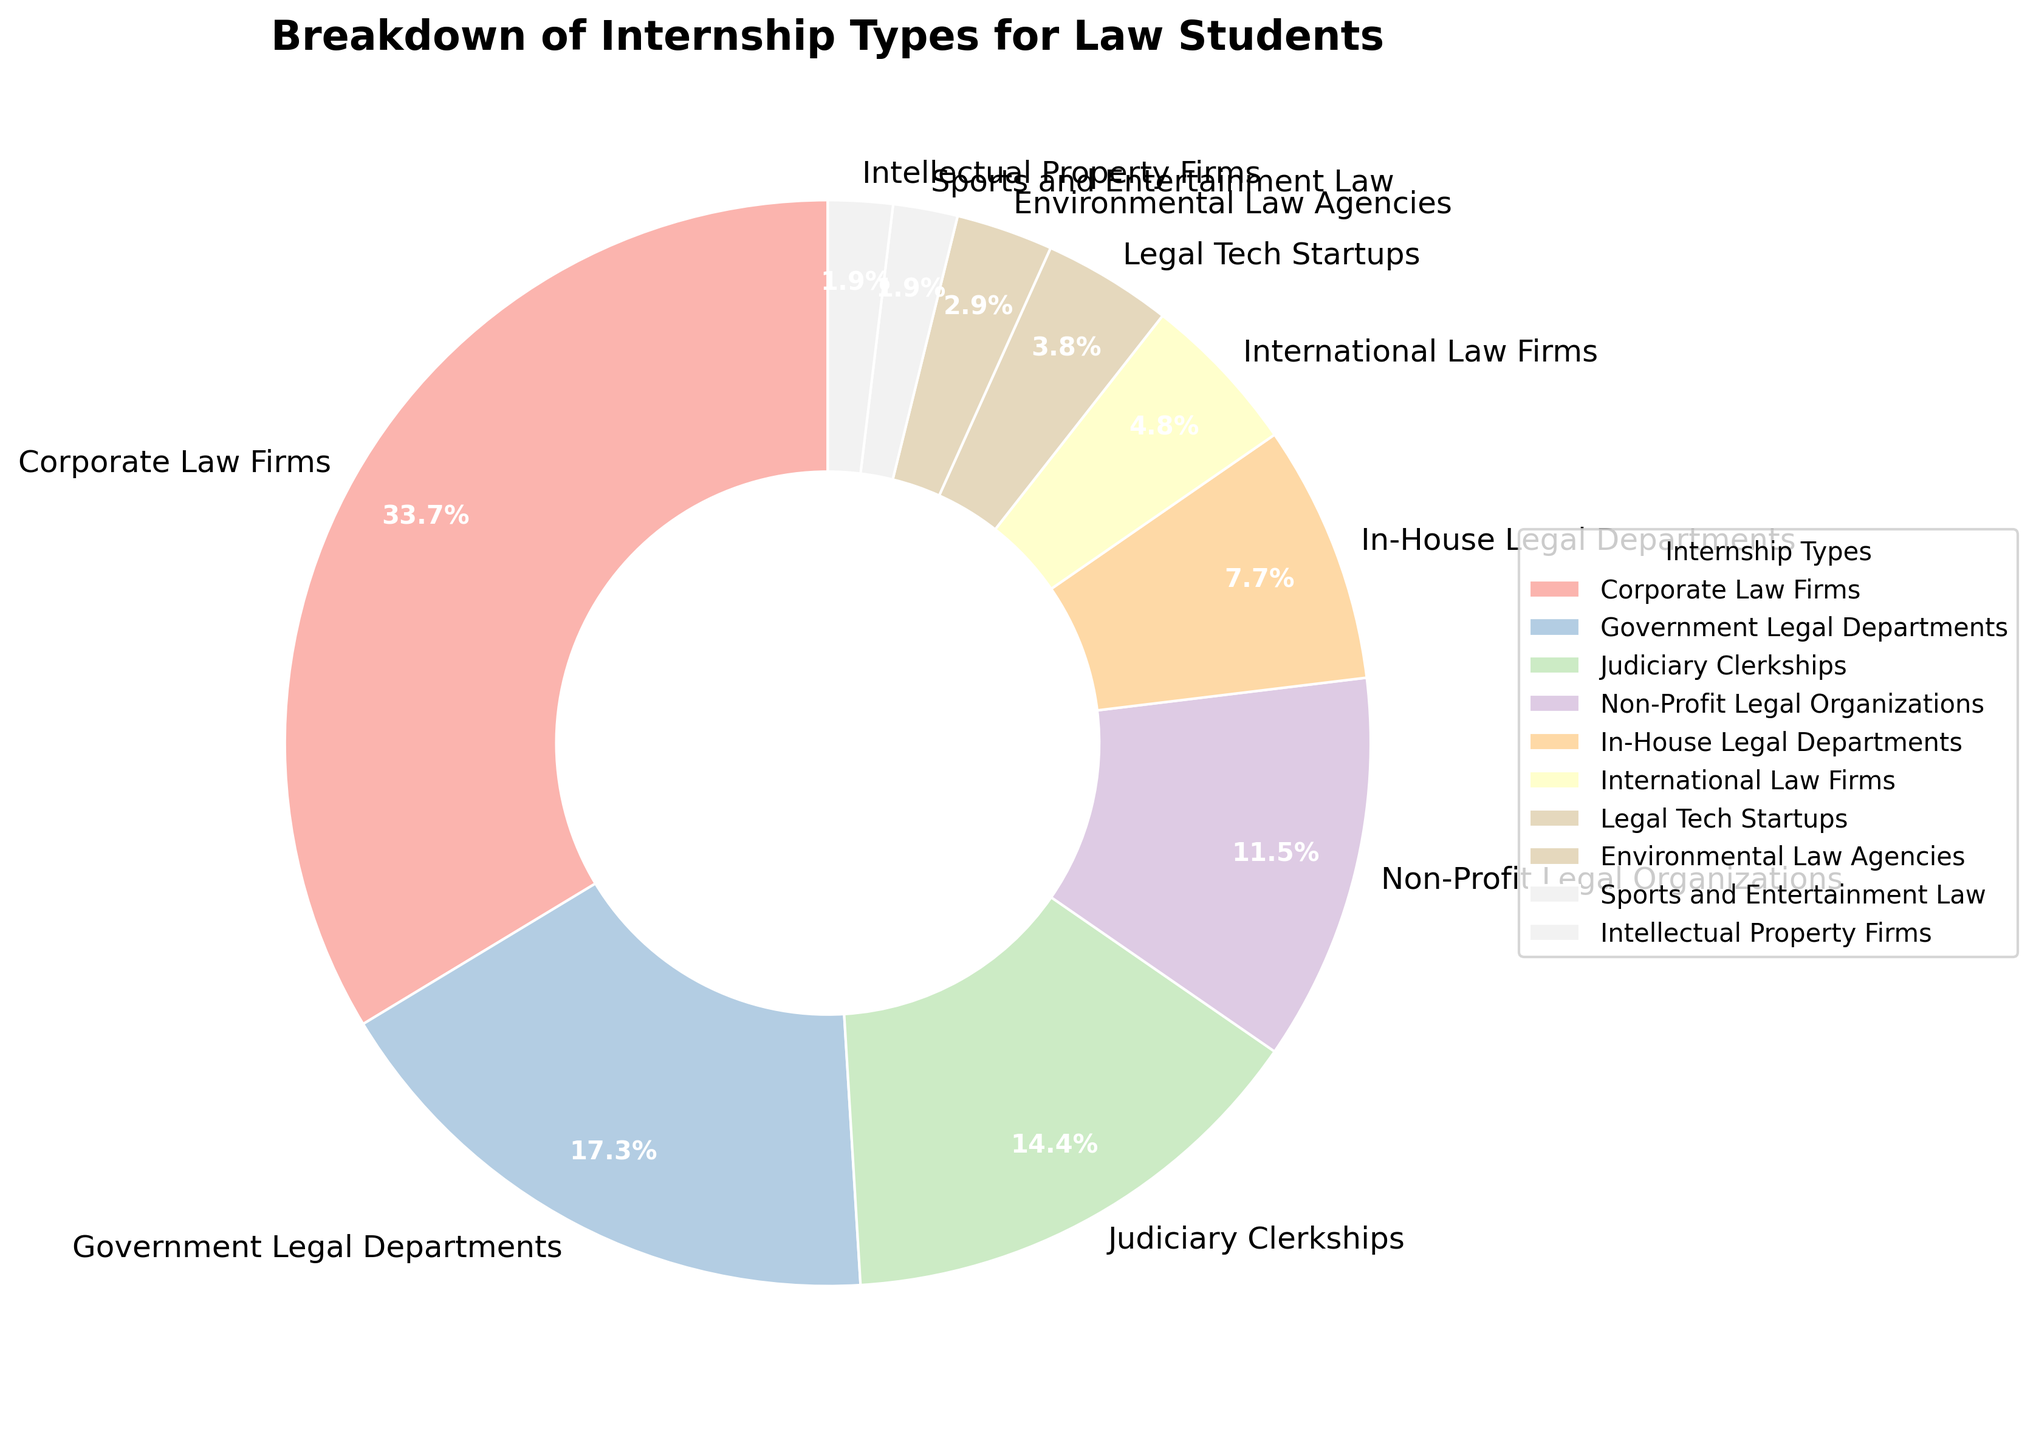Which type of internship has the highest percentage? The pie chart shows a variety of internship types, each with a distinct percentage. By looking at the chart, we identify the largest section which corresponds to Corporate Law Firms.
Answer: Corporate Law Firms How much more percentage do Corporate Law Firms internships have compared to Judiciary Clerkships? From the chart, we see that the percentage for Corporate Law Firms is 35% and for Judiciary Clerkships is 15%. Subtract the percentage for Judiciary Clerkships from Corporate Law Firms to get the difference 35% - 15% = 20%.
Answer: 20% Which internship types have a lower percentage than Legal Tech Startups? The pie chart indicates that Legal Tech Startups have a percentage of 4%. Any internship type with a percentage lower than 4% is the answer. These are Environmental Law Agencies with 3%, Sports and Entertainment Law with 2%, and Intellectual Property Firms with 2%.
Answer: Environmental Law Agencies, Sports and Entertainment Law, Intellectual Property Firms What's the combined percentage of In-House Legal Departments and International Law Firms internships? The chart shows In-House Legal Departments at 8% and International Law Firms at 5%. Add these two percentages to get the combined value 8% + 5% = 13%.
Answer: 13% What is the smallest slice in the pie chart, and what is its percentage? To find the smallest slice in the pie chart, we compare each section's size. The smallest percentage visible is 2%, which is shared by both Sports and Entertainment Law and Intellectual Property Firms.
Answer: Sports and Entertainment Law and Intellectual Property Firms at 2% By how much does the percentage of Government Legal Departments exceed the percentage of Non-Profit Legal Organizations? The pie chart shows percentages for Government Legal Departments at 18% and Non-Profit Legal Organizations at 12%. Subtract the latter from the former to get 18% - 12% = 6%.
Answer: 6% What's the total percentage of internships accounted for by Government Legal Departments, Judiciary Clerkships, and Non-Profit Legal Organizations? We add the percentages of the Government Legal Departments (18%), Judiciary Clerkships (15%), and Non-Profit Legal Organizations (12%) to get the total 18% + 15% + 12% = 45%.
Answer: 45% Which internships have a higher percentage than In-House Legal Departments? The pie chart shows that In-House Legal Departments have an 8% share. We look for all sections with a percentage higher than 8%, which are Corporate Law Firms at 35%, Government Legal Departments at 18%, Judiciary Clerkships at 15%, and Non-Profit Legal Organizations at 12%.
Answer: Corporate Law Firms, Government Legal Departments, Judiciary Clerkships, Non-Profit Legal Organizations What is the combined percentage of all internships that have a percentage less than 10%? We identify all internships with less than 10% from the chart: In-House Legal Departments (8%), International Law Firms (5%), Legal Tech Startups (4%), Environmental Law Agencies (3%), Sports and Entertainment Law (2%), and Intellectual Property Firms (2%). Adding these up: 8% + 5% + 4% + 3% + 2% + 2% = 24%.
Answer: 24% What percentage of internships fall under non-traditional sectors (Legal Tech Startups, Environmental Law Agencies, and Sports and Entertainment Law)? To determine this, sum the percentages of Legal Tech Startups (4%), Environmental Law Agencies (3%), and Sports and Entertainment Law (2%). The total is 4% + 3% + 2% = 9%.
Answer: 9% 